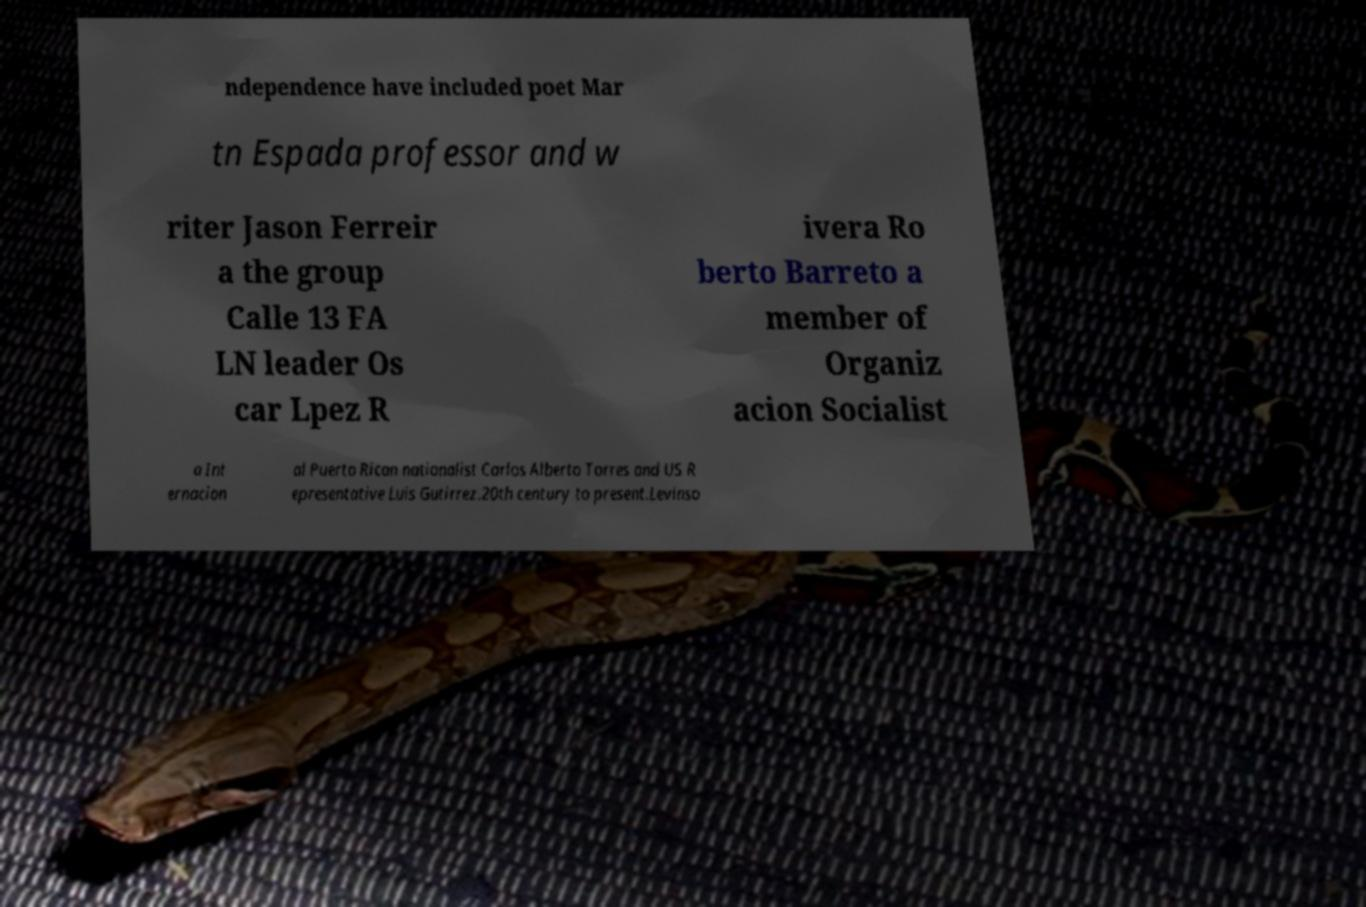For documentation purposes, I need the text within this image transcribed. Could you provide that? ndependence have included poet Mar tn Espada professor and w riter Jason Ferreir a the group Calle 13 FA LN leader Os car Lpez R ivera Ro berto Barreto a member of Organiz acion Socialist a Int ernacion al Puerto Rican nationalist Carlos Alberto Torres and US R epresentative Luis Gutirrez.20th century to present.Levinso 